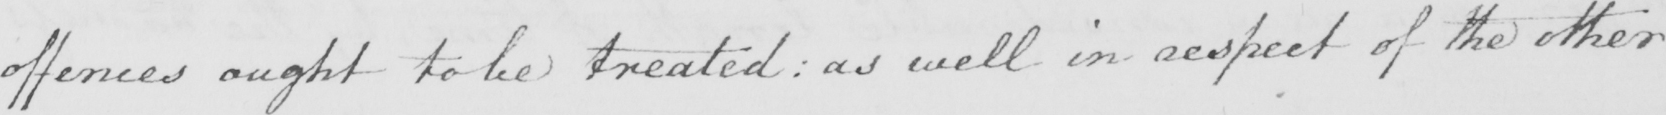What does this handwritten line say? offences ought to be treated :  as well in respect of the other 